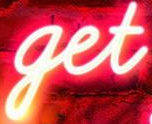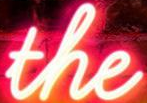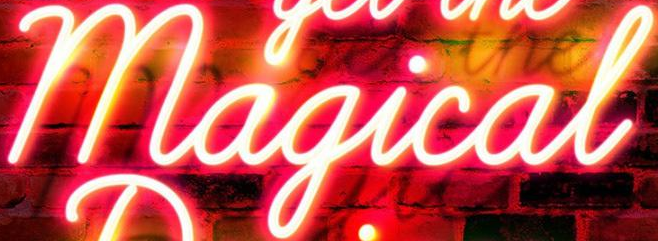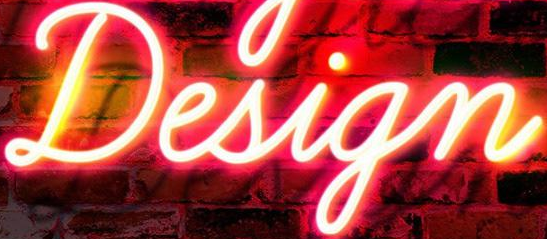Transcribe the words shown in these images in order, separated by a semicolon. get; the; Magical; Design 